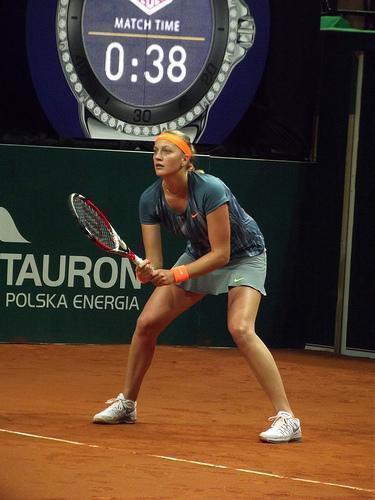How many players can be seen?
Give a very brief answer. 1. 